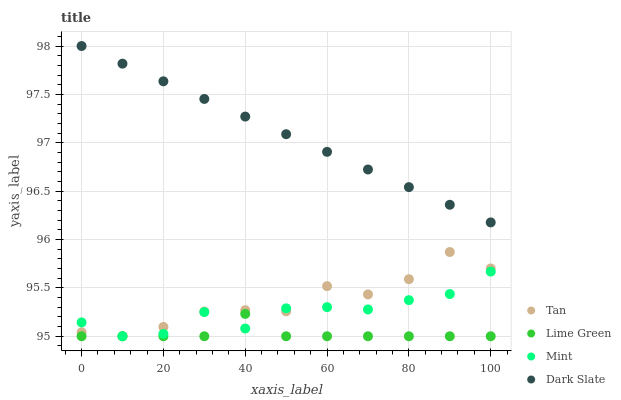Does Lime Green have the minimum area under the curve?
Answer yes or no. Yes. Does Dark Slate have the maximum area under the curve?
Answer yes or no. Yes. Does Tan have the minimum area under the curve?
Answer yes or no. No. Does Tan have the maximum area under the curve?
Answer yes or no. No. Is Dark Slate the smoothest?
Answer yes or no. Yes. Is Tan the roughest?
Answer yes or no. Yes. Is Lime Green the smoothest?
Answer yes or no. No. Is Lime Green the roughest?
Answer yes or no. No. Does Mint have the lowest value?
Answer yes or no. Yes. Does Dark Slate have the lowest value?
Answer yes or no. No. Does Dark Slate have the highest value?
Answer yes or no. Yes. Does Tan have the highest value?
Answer yes or no. No. Is Tan less than Dark Slate?
Answer yes or no. Yes. Is Dark Slate greater than Lime Green?
Answer yes or no. Yes. Does Mint intersect Tan?
Answer yes or no. Yes. Is Mint less than Tan?
Answer yes or no. No. Is Mint greater than Tan?
Answer yes or no. No. Does Tan intersect Dark Slate?
Answer yes or no. No. 